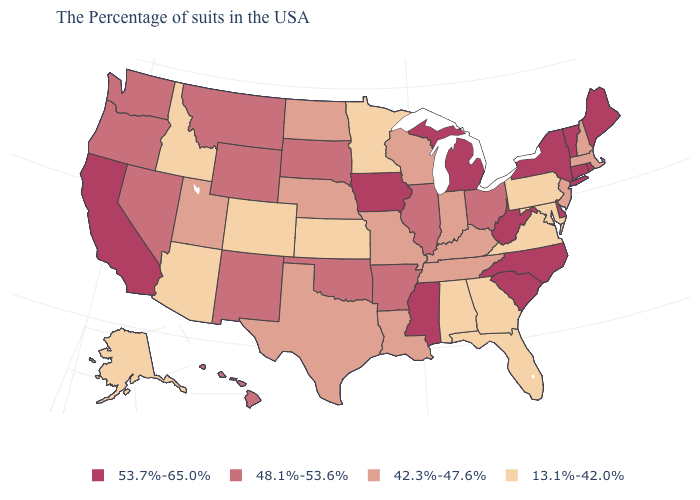Which states have the lowest value in the USA?
Be succinct. Maryland, Pennsylvania, Virginia, Florida, Georgia, Alabama, Minnesota, Kansas, Colorado, Arizona, Idaho, Alaska. Which states have the highest value in the USA?
Be succinct. Maine, Rhode Island, Vermont, Connecticut, New York, Delaware, North Carolina, South Carolina, West Virginia, Michigan, Mississippi, Iowa, California. What is the value of North Dakota?
Short answer required. 42.3%-47.6%. What is the value of Florida?
Concise answer only. 13.1%-42.0%. Among the states that border Vermont , which have the lowest value?
Be succinct. Massachusetts, New Hampshire. Which states have the lowest value in the South?
Answer briefly. Maryland, Virginia, Florida, Georgia, Alabama. Name the states that have a value in the range 53.7%-65.0%?
Be succinct. Maine, Rhode Island, Vermont, Connecticut, New York, Delaware, North Carolina, South Carolina, West Virginia, Michigan, Mississippi, Iowa, California. What is the highest value in the Northeast ?
Keep it brief. 53.7%-65.0%. Among the states that border Iowa , which have the highest value?
Concise answer only. Illinois, South Dakota. What is the lowest value in the West?
Be succinct. 13.1%-42.0%. Does North Dakota have the lowest value in the MidWest?
Short answer required. No. What is the value of Louisiana?
Concise answer only. 42.3%-47.6%. What is the value of Oklahoma?
Give a very brief answer. 48.1%-53.6%. Name the states that have a value in the range 48.1%-53.6%?
Concise answer only. Ohio, Illinois, Arkansas, Oklahoma, South Dakota, Wyoming, New Mexico, Montana, Nevada, Washington, Oregon, Hawaii. Is the legend a continuous bar?
Be succinct. No. 